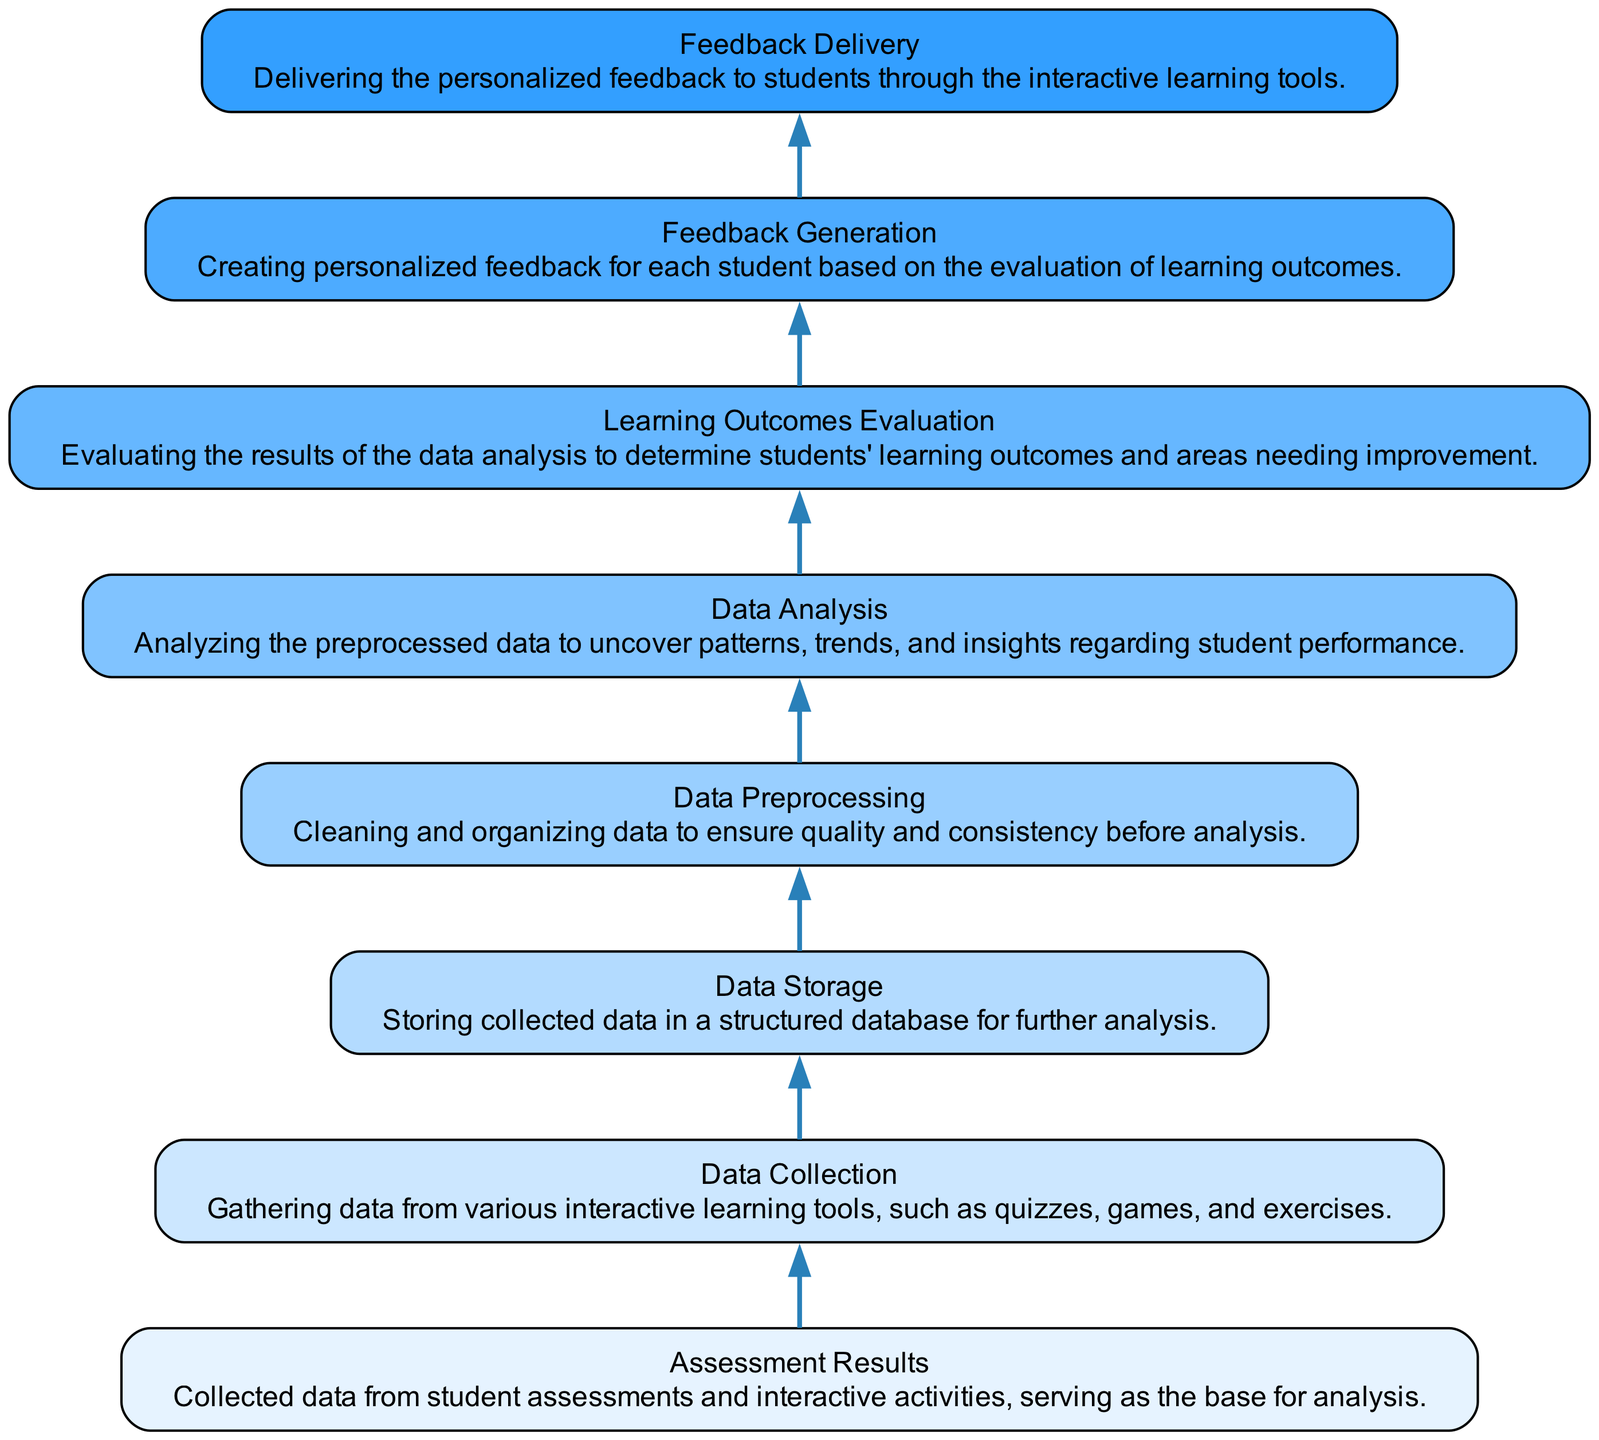What is the starting point of the flow chart? The starting point is "Assessment Results," which serves as the base for analysis in this flow.
Answer: Assessment Results How many nodes are in the diagram? Count the elements listed: there are eight nodes that represent different stages in the student progress analysis flow.
Answer: Eight What is the last node in the flow? The last node in the flow chart is "Feedback Delivery," where personalized feedback is delivered to students.
Answer: Feedback Delivery What happens after data collection? After data collection, the data is sent to "Data Storage" where it is structured for further analysis.
Answer: Data Storage Which node comes before feedback generation? The node preceding "Feedback Generation" is "Learning Outcomes Evaluation," which evaluates student performance before feedback is created.
Answer: Learning Outcomes Evaluation How are the nodes connected in terms of data flow? The nodes are connected in a sequential manner, each leading to the next stage of the process, showing a clear flow from data collection to feedback delivery.
Answer: Sequentially What is the purpose of data preprocessing? The purpose of "Data Preprocessing" is to clean and organize data to ensure quality and consistency before conducting analysis.
Answer: Clean and organize data In which step are patterns of student performance uncovered? Patterns of student performance are uncovered during the "Data Analysis" step, which analyzes the preprocessed data.
Answer: Data Analysis What is the relationship between data analysis and learning outcomes evaluation? "Data Analysis" feeds into "Learning Outcomes Evaluation," as the former helps determine the results needed for the latter.
Answer: Feeds into 